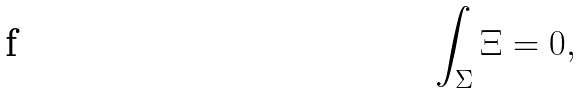<formula> <loc_0><loc_0><loc_500><loc_500>\int _ { \Sigma } \Xi = 0 ,</formula> 